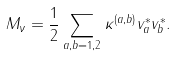<formula> <loc_0><loc_0><loc_500><loc_500>M _ { \nu } = \frac { 1 } { 2 } \sum _ { a , b = 1 , 2 } \kappa ^ { ( a , b ) } v _ { a } ^ { * } v _ { b } ^ { * } .</formula> 